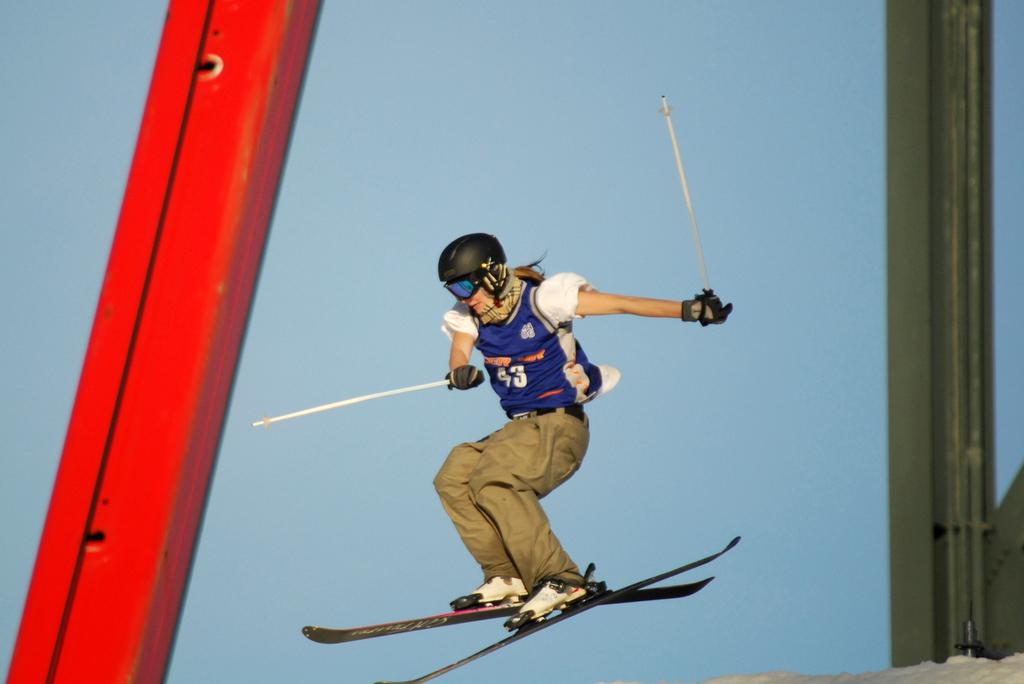Who is present in the image? There is a person in the image. What is the person wearing? The person is wearing ski boards. What is the person holding in her hands? The person is holding sticks in her hands. What can be seen on the sides of the image? There are metal poles on the left and right sides of the image. Can you see the person swimming in the image? No, the person is not swimming in the image; they are wearing ski boards and holding sticks, which suggests they are participating in a winter sport. 